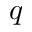<formula> <loc_0><loc_0><loc_500><loc_500>q</formula> 